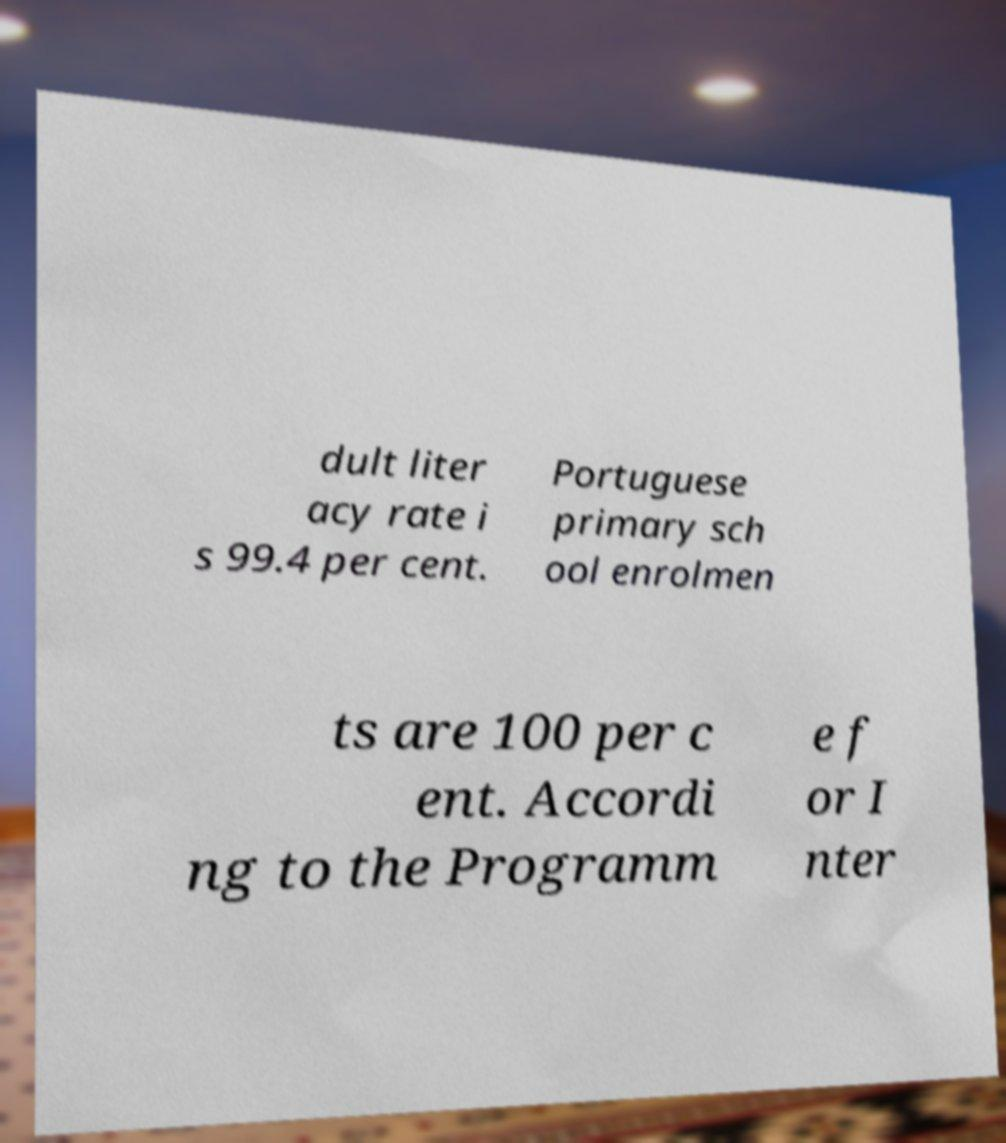Can you accurately transcribe the text from the provided image for me? dult liter acy rate i s 99.4 per cent. Portuguese primary sch ool enrolmen ts are 100 per c ent. Accordi ng to the Programm e f or I nter 